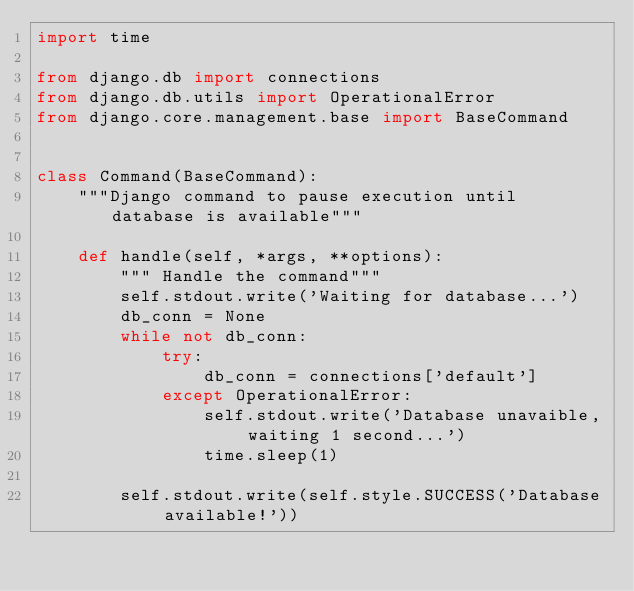Convert code to text. <code><loc_0><loc_0><loc_500><loc_500><_Python_>import time

from django.db import connections
from django.db.utils import OperationalError
from django.core.management.base import BaseCommand


class Command(BaseCommand):
    """Django command to pause execution until database is available"""

    def handle(self, *args, **options):
        """ Handle the command"""
        self.stdout.write('Waiting for database...')
        db_conn = None
        while not db_conn:
            try:
                db_conn = connections['default']
            except OperationalError:
                self.stdout.write('Database unavaible, waiting 1 second...')
                time.sleep(1)

        self.stdout.write(self.style.SUCCESS('Database available!'))
</code> 